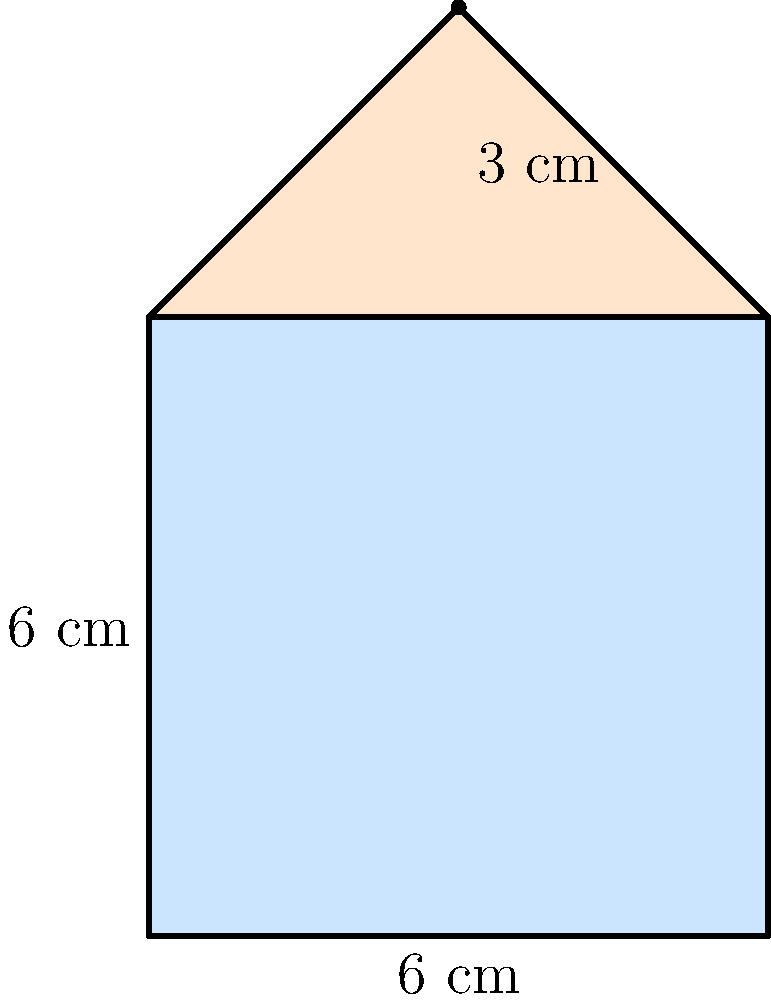For your upcoming quilting project, you've designed a charming pattern consisting of a square with an equilateral triangle on top. The square measures 6 cm on each side, and the triangle has a height of 3 cm. What is the total area of this delightful quilting pattern in square centimetres? Let's approach this step-by-step, dear:

1) First, let's calculate the area of the square:
   $$ \text{Area of square} = \text{side} \times \text{side} = 6 \text{ cm} \times 6 \text{ cm} = 36 \text{ cm}^2 $$

2) Now, for the triangle. We know its height, but we need to find its base. The base is the same as the side of the square, 6 cm.

3) The area of a triangle is given by the formula: $\frac{1}{2} \times \text{base} \times \text{height}$
   $$ \text{Area of triangle} = \frac{1}{2} \times 6 \text{ cm} \times 3 \text{ cm} = 9 \text{ cm}^2 $$

4) To get the total area, we simply add the areas of the square and the triangle:
   $$ \text{Total Area} = \text{Area of square} + \text{Area of triangle} $$
   $$ \text{Total Area} = 36 \text{ cm}^2 + 9 \text{ cm}^2 = 45 \text{ cm}^2 $$

There we have it! The total area of our lovely quilting pattern is 45 square centimetres.
Answer: 45 cm² 